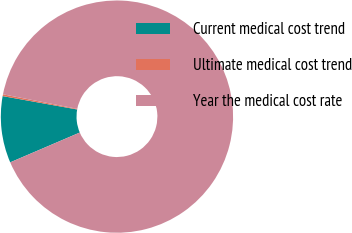Convert chart. <chart><loc_0><loc_0><loc_500><loc_500><pie_chart><fcel>Current medical cost trend<fcel>Ultimate medical cost trend<fcel>Year the medical cost rate<nl><fcel>9.27%<fcel>0.25%<fcel>90.48%<nl></chart> 